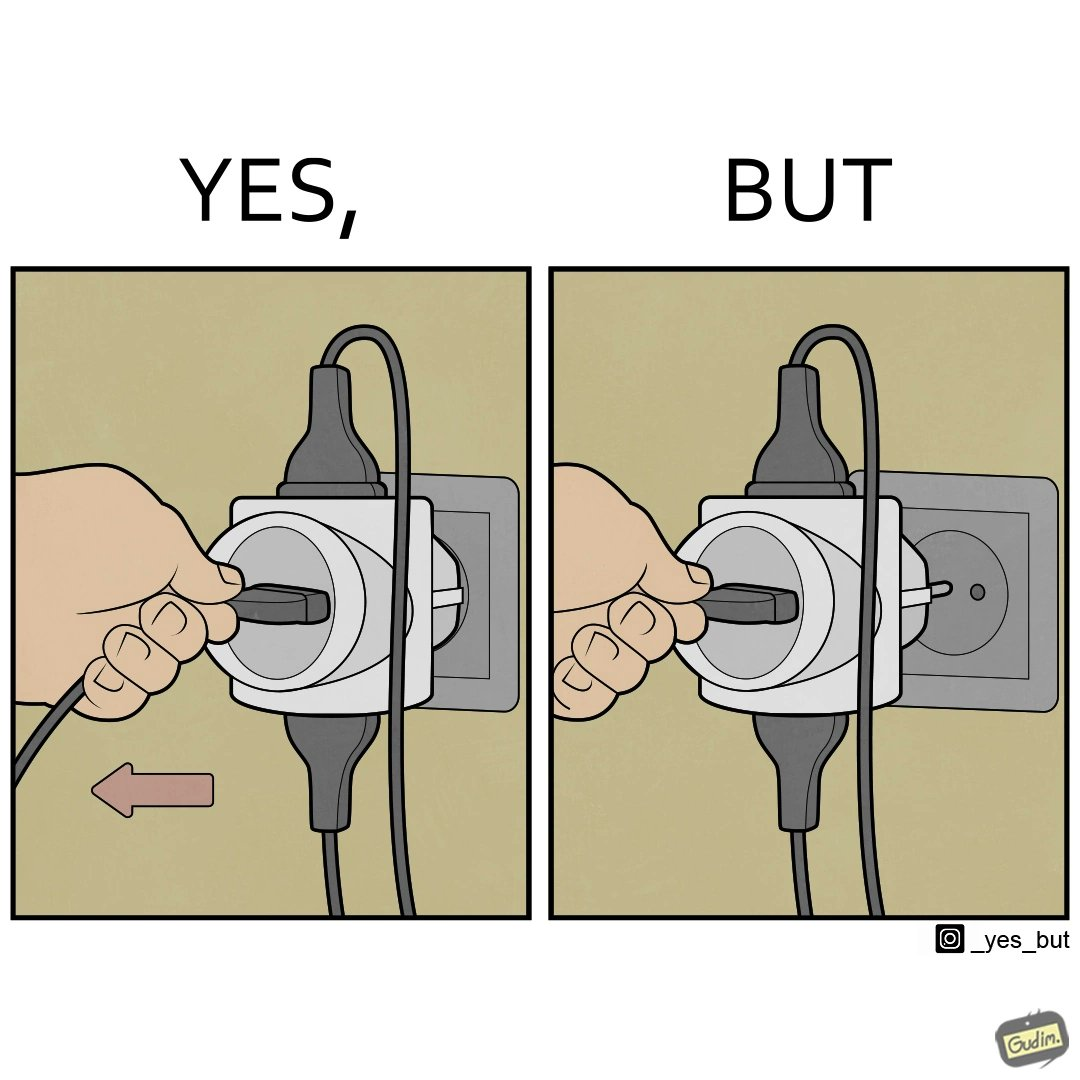Describe what you see in this image. The image is ironic, because some person is trying to plug out one pin from the multi pin plug but due to tight fitting the multi pin plug socket itself is getting pulled off disconnecting the power supply to other devices even when it is not required 